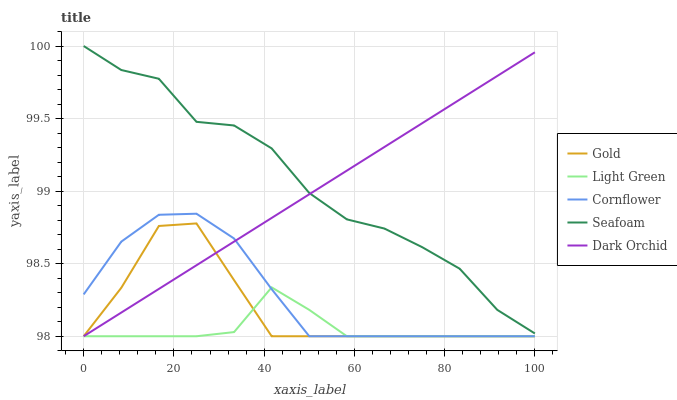Does Cornflower have the minimum area under the curve?
Answer yes or no. No. Does Cornflower have the maximum area under the curve?
Answer yes or no. No. Is Cornflower the smoothest?
Answer yes or no. No. Is Cornflower the roughest?
Answer yes or no. No. Does Seafoam have the lowest value?
Answer yes or no. No. Does Cornflower have the highest value?
Answer yes or no. No. Is Gold less than Seafoam?
Answer yes or no. Yes. Is Seafoam greater than Light Green?
Answer yes or no. Yes. Does Gold intersect Seafoam?
Answer yes or no. No. 